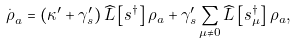<formula> <loc_0><loc_0><loc_500><loc_500>\overset { . } { \rho } _ { a } = \left ( \kappa ^ { \prime } + \gamma _ { s } ^ { \prime } \right ) \widehat { L } \left [ s ^ { \dagger } \right ] \rho _ { a } + \gamma _ { s } ^ { \prime } \sum _ { \mu \neq 0 } \widehat { L } \left [ s _ { \mu } ^ { \dagger } \right ] \rho _ { a } ,</formula> 